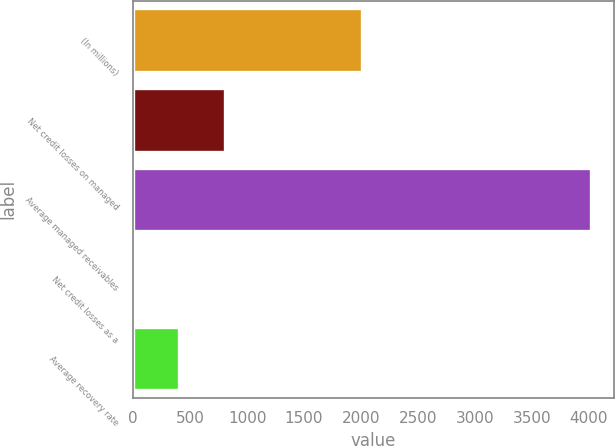Convert chart. <chart><loc_0><loc_0><loc_500><loc_500><bar_chart><fcel>(In millions)<fcel>Net credit losses on managed<fcel>Average managed receivables<fcel>Net credit losses as a<fcel>Average recovery rate<nl><fcel>2009<fcel>805.6<fcel>4021<fcel>1.74<fcel>403.67<nl></chart> 